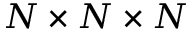<formula> <loc_0><loc_0><loc_500><loc_500>N \times N \times N</formula> 